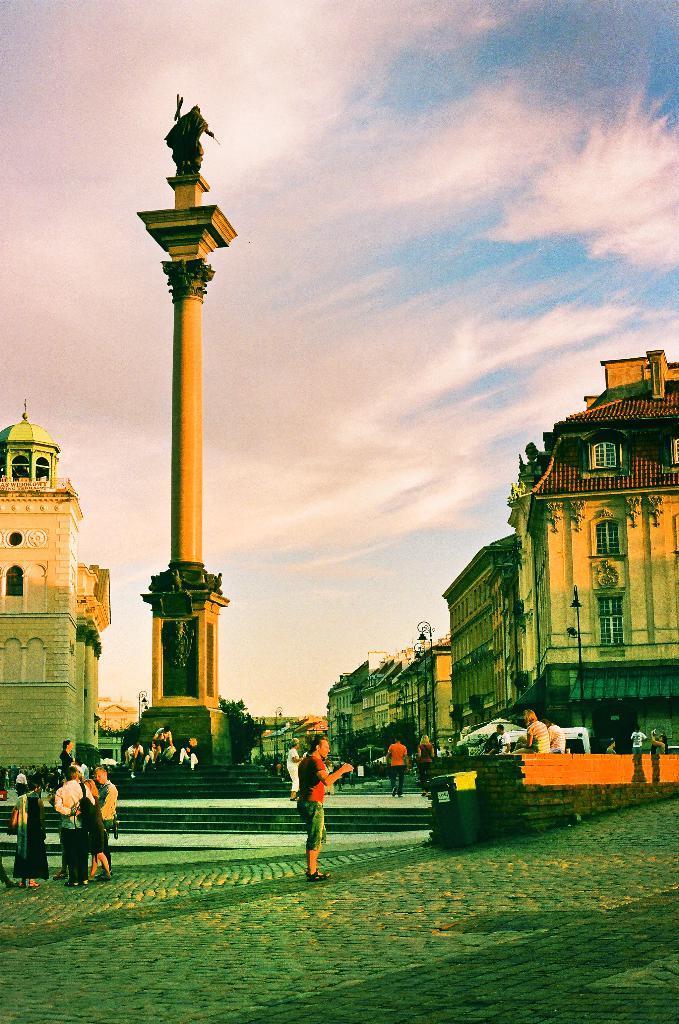Please provide a concise description of this image. In this image we can see group of persons holding an object. And there is a statue and a sky. 